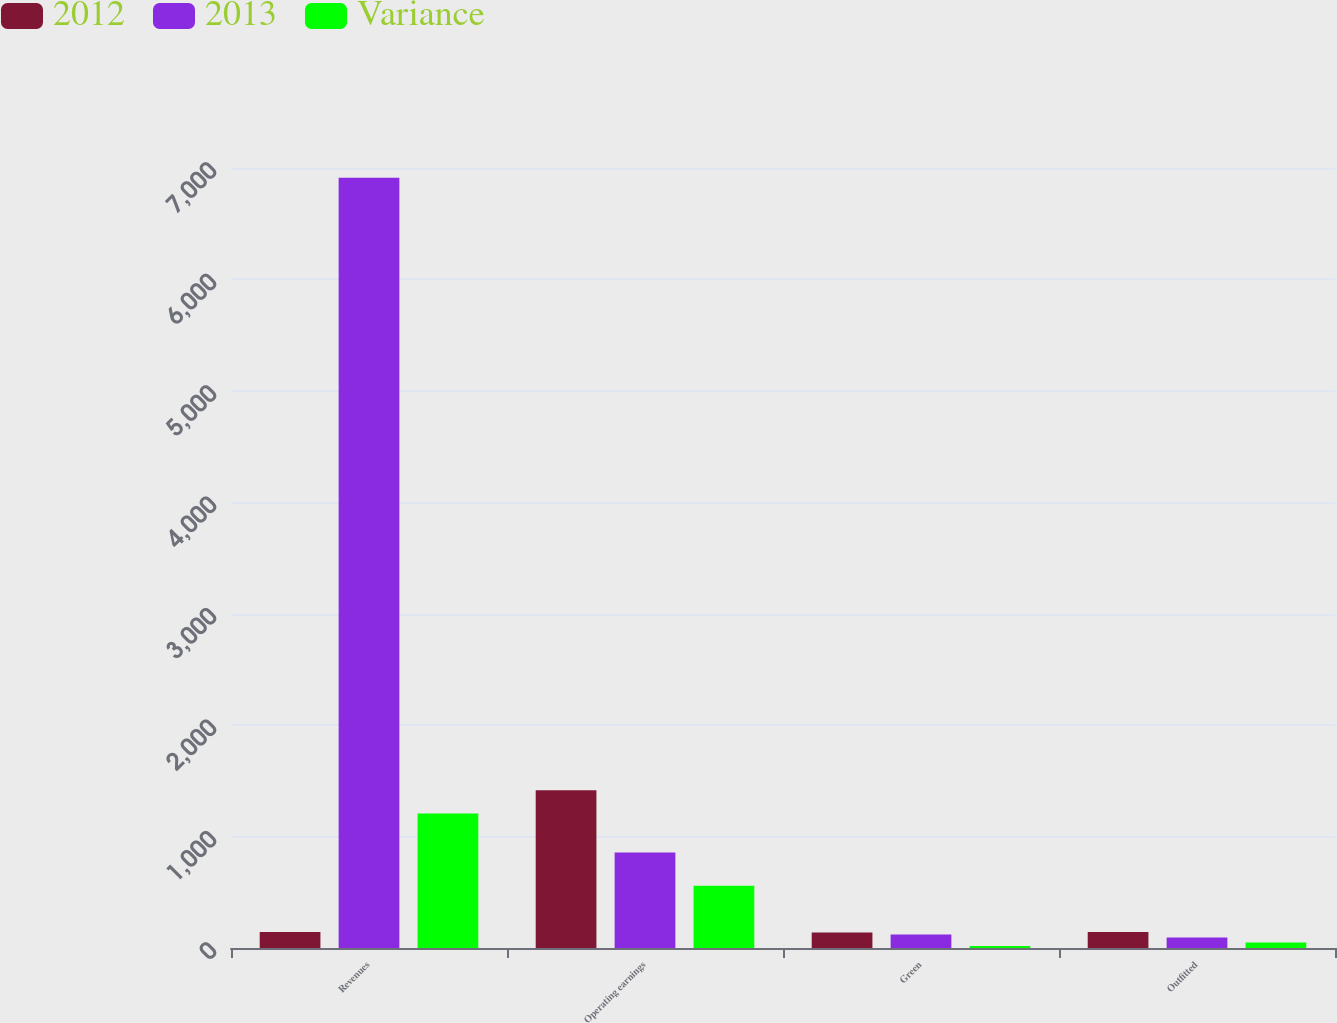Convert chart to OTSL. <chart><loc_0><loc_0><loc_500><loc_500><stacked_bar_chart><ecel><fcel>Revenues<fcel>Operating earnings<fcel>Green<fcel>Outfitted<nl><fcel>2012<fcel>144<fcel>1416<fcel>139<fcel>144<nl><fcel>2013<fcel>6912<fcel>858<fcel>121<fcel>94<nl><fcel>Variance<fcel>1206<fcel>558<fcel>18<fcel>50<nl></chart> 